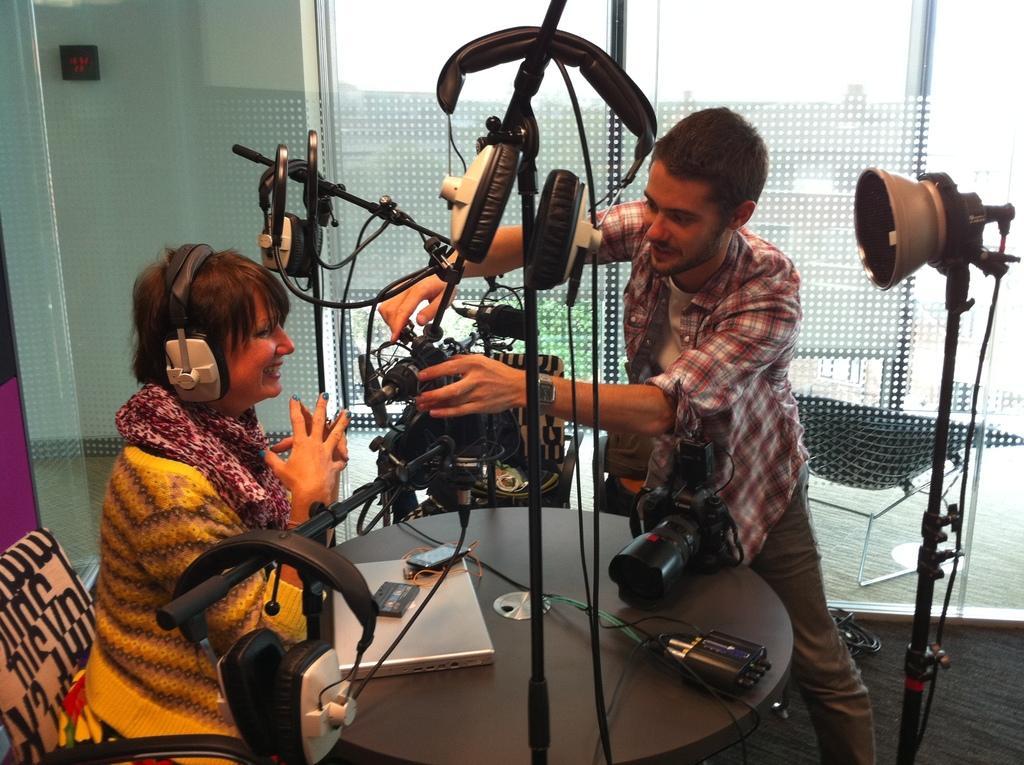How would you summarize this image in a sentence or two? There is a person sitting on a chair, wearing a headset and smiling in front of a table on which, there is a laptop, camera and other objects. Above this table, there are mice attached to the stands. Beside this table, there is a person adjusting this mic near a light which is attached to the stand. In the background, there is a glass window which is attached to the wall. 